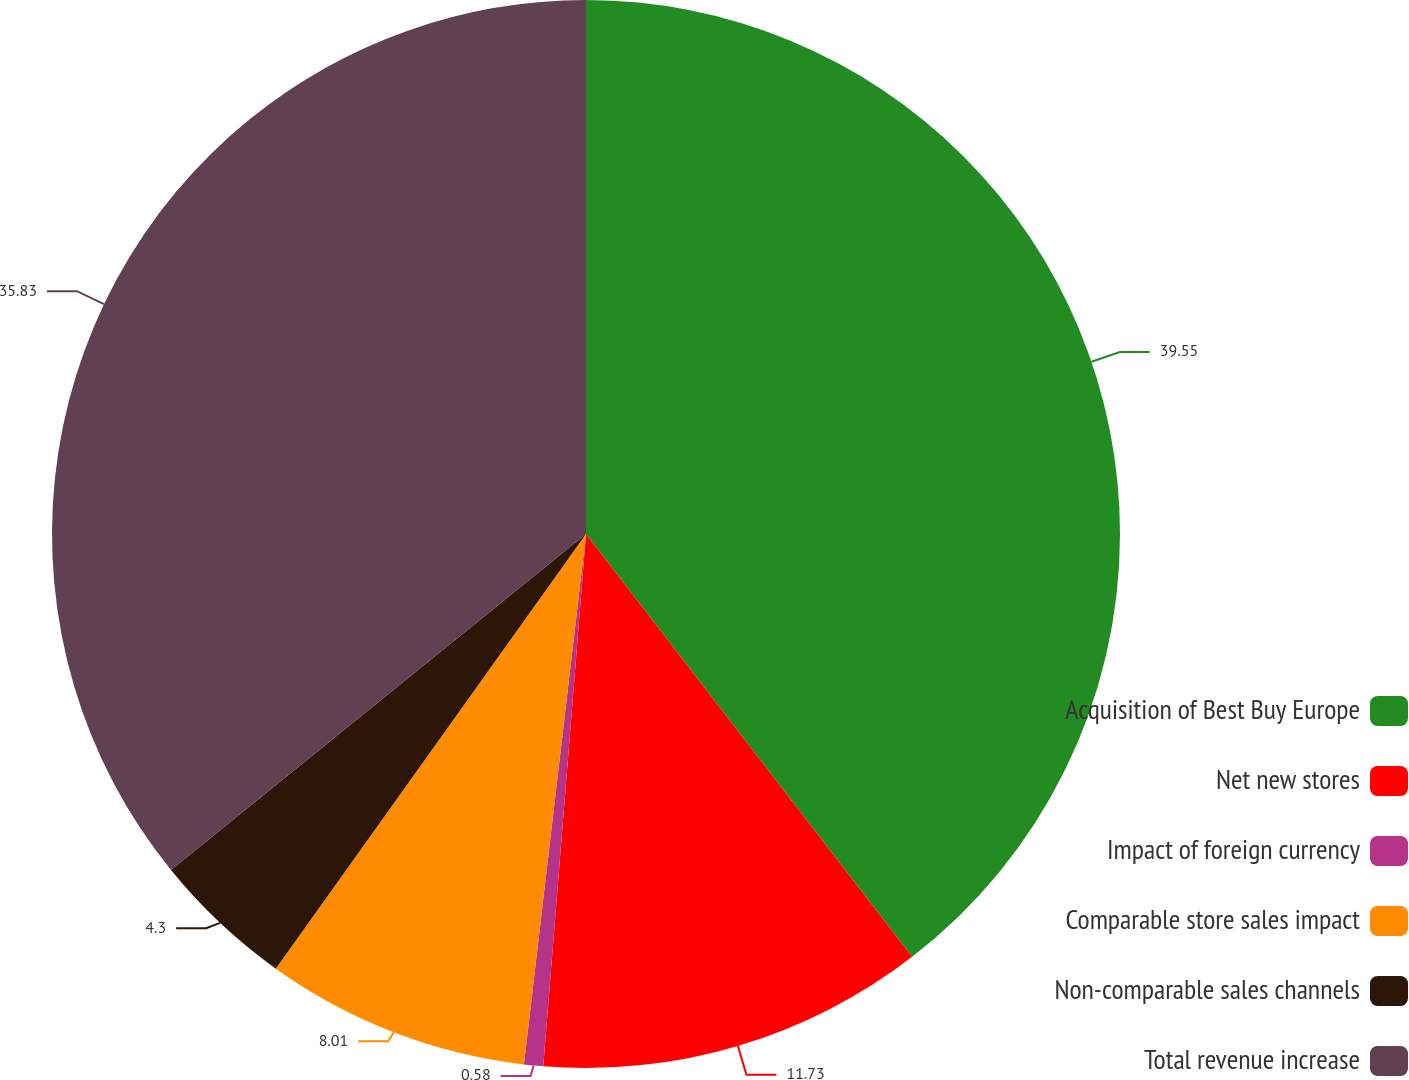Convert chart to OTSL. <chart><loc_0><loc_0><loc_500><loc_500><pie_chart><fcel>Acquisition of Best Buy Europe<fcel>Net new stores<fcel>Impact of foreign currency<fcel>Comparable store sales impact<fcel>Non-comparable sales channels<fcel>Total revenue increase<nl><fcel>39.54%<fcel>11.73%<fcel>0.58%<fcel>8.01%<fcel>4.3%<fcel>35.83%<nl></chart> 